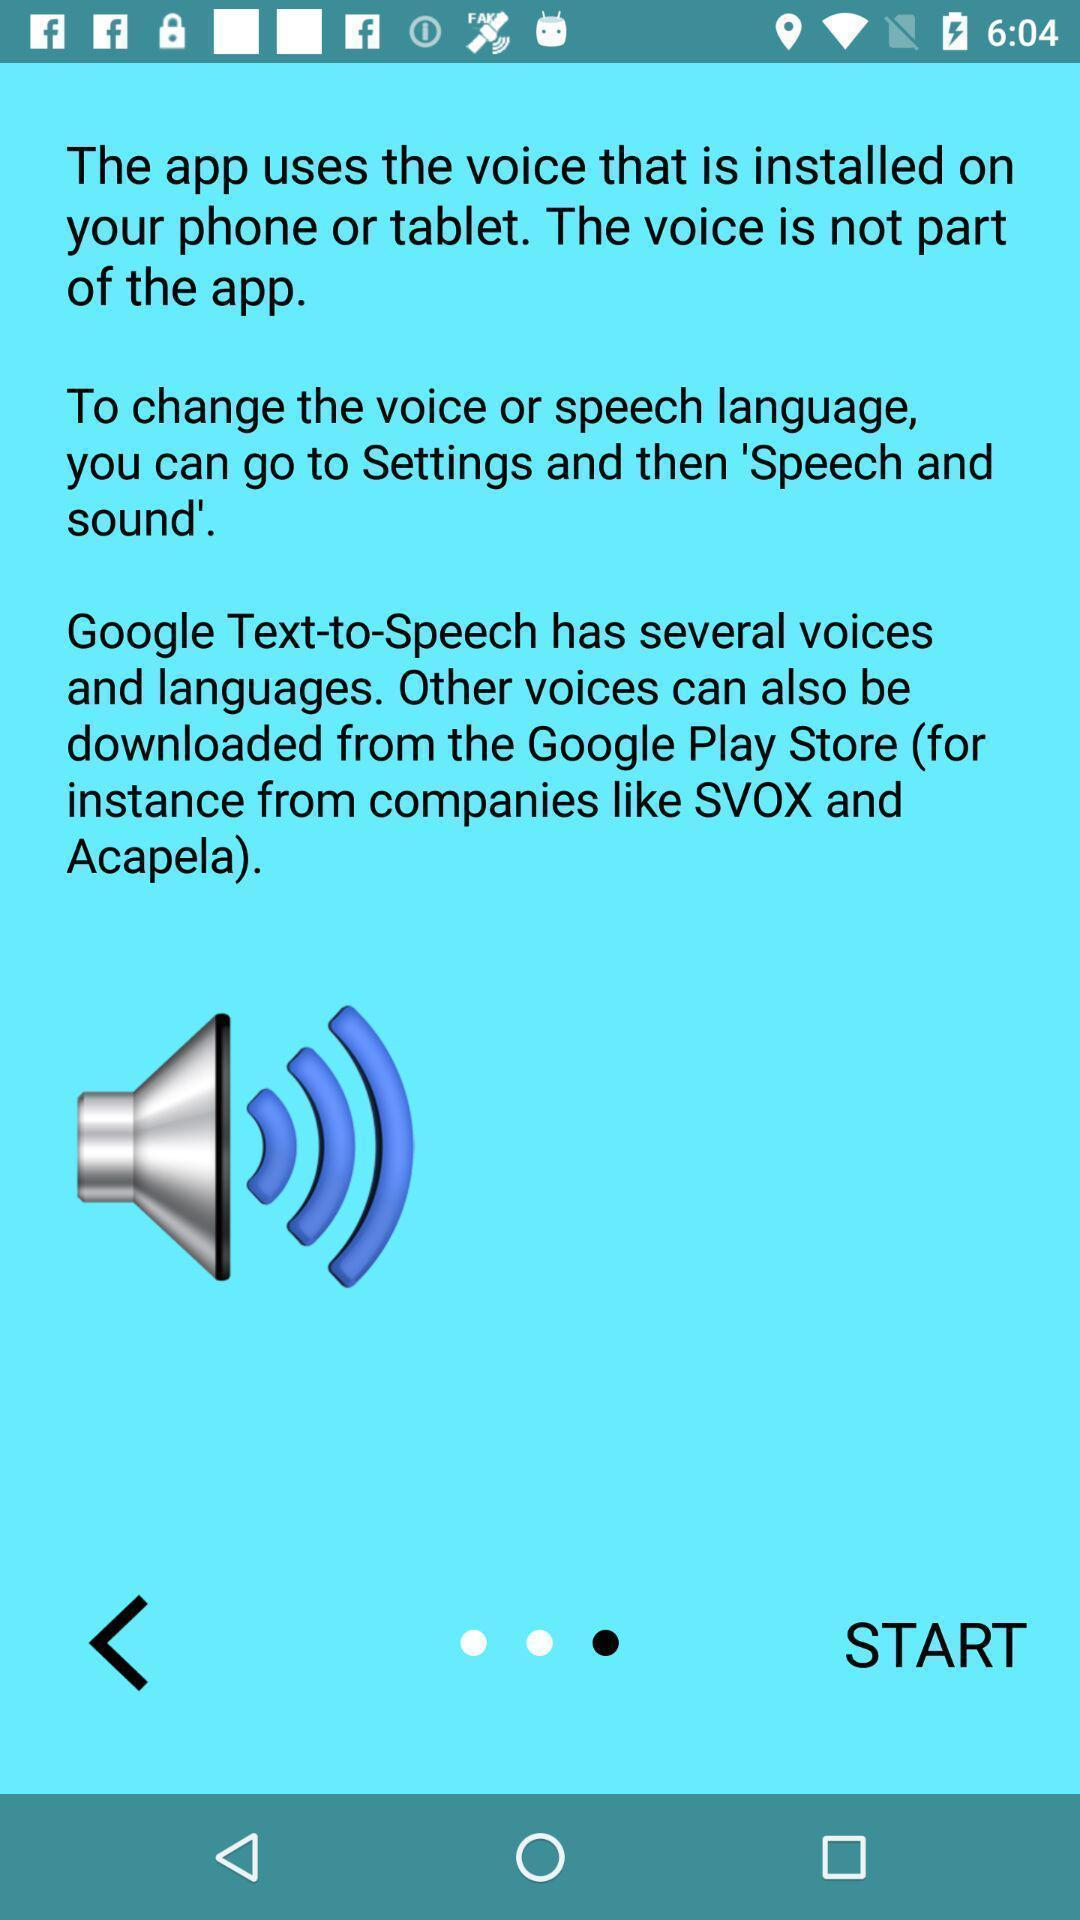Please provide a description for this image. Welcome page for a voice application. 